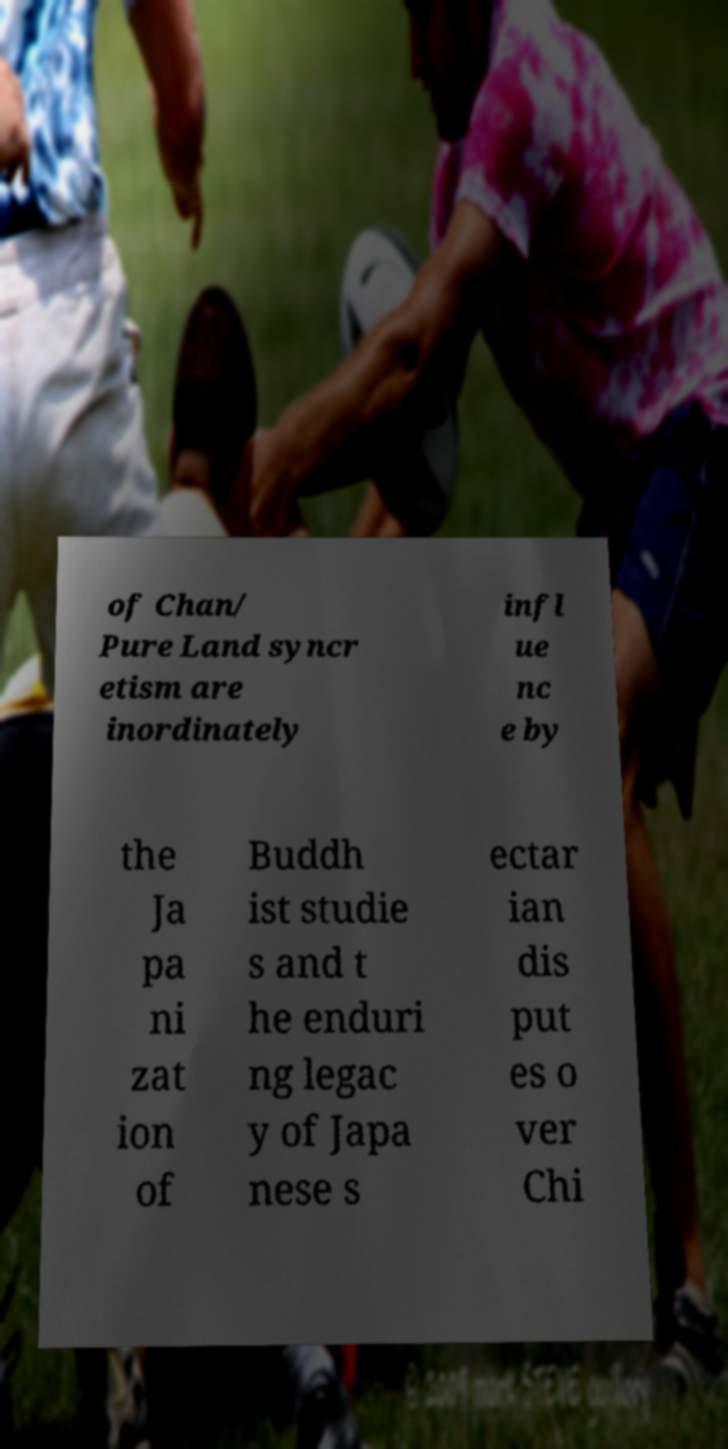There's text embedded in this image that I need extracted. Can you transcribe it verbatim? of Chan/ Pure Land syncr etism are inordinately infl ue nc e by the Ja pa ni zat ion of Buddh ist studie s and t he enduri ng legac y of Japa nese s ectar ian dis put es o ver Chi 